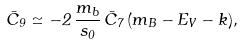Convert formula to latex. <formula><loc_0><loc_0><loc_500><loc_500>\bar { C } _ { 9 } \simeq - 2 \, \frac { m _ { b } } { s _ { 0 } } \, \bar { C } _ { 7 } \, ( m _ { B } - E _ { V } - k ) ,</formula> 